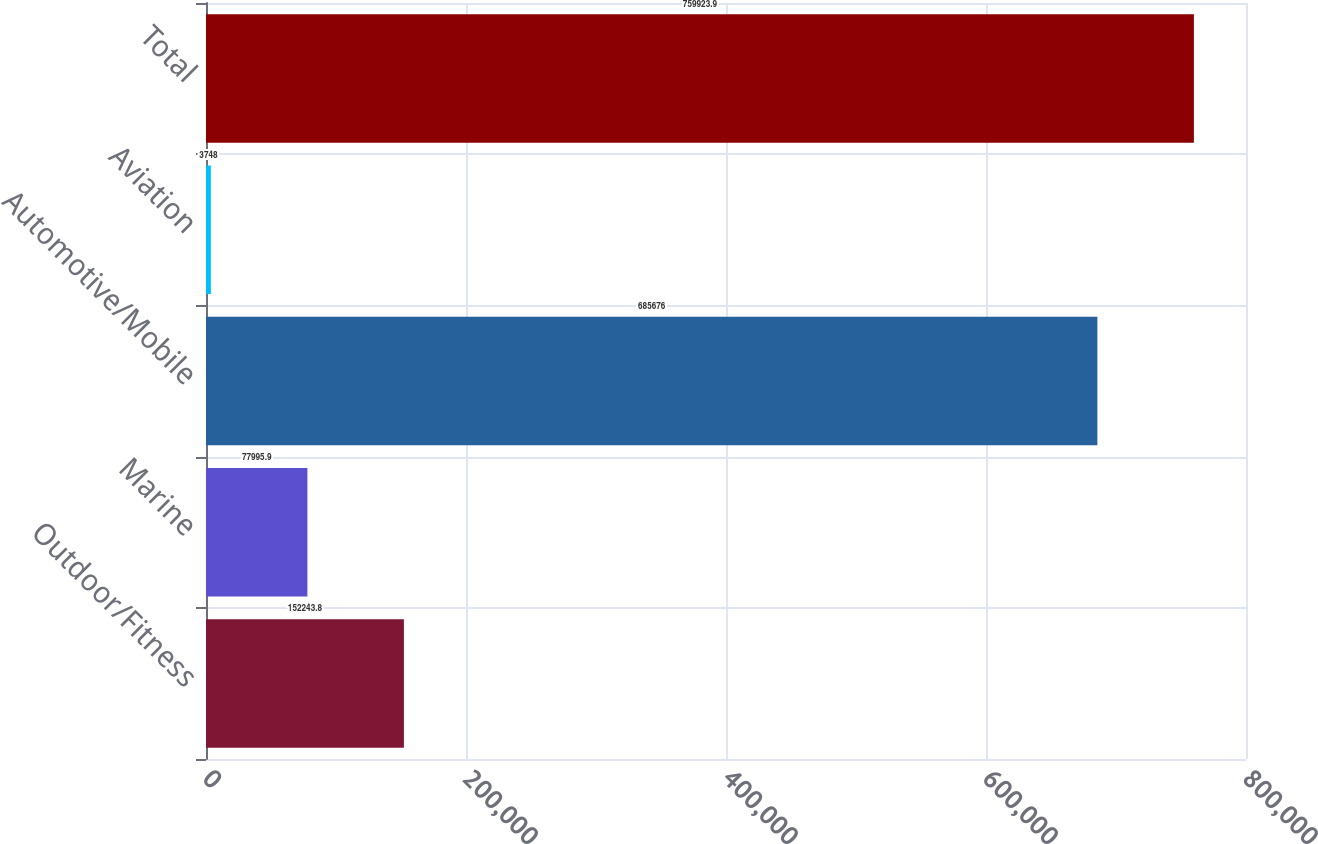Convert chart to OTSL. <chart><loc_0><loc_0><loc_500><loc_500><bar_chart><fcel>Outdoor/Fitness<fcel>Marine<fcel>Automotive/Mobile<fcel>Aviation<fcel>Total<nl><fcel>152244<fcel>77995.9<fcel>685676<fcel>3748<fcel>759924<nl></chart> 